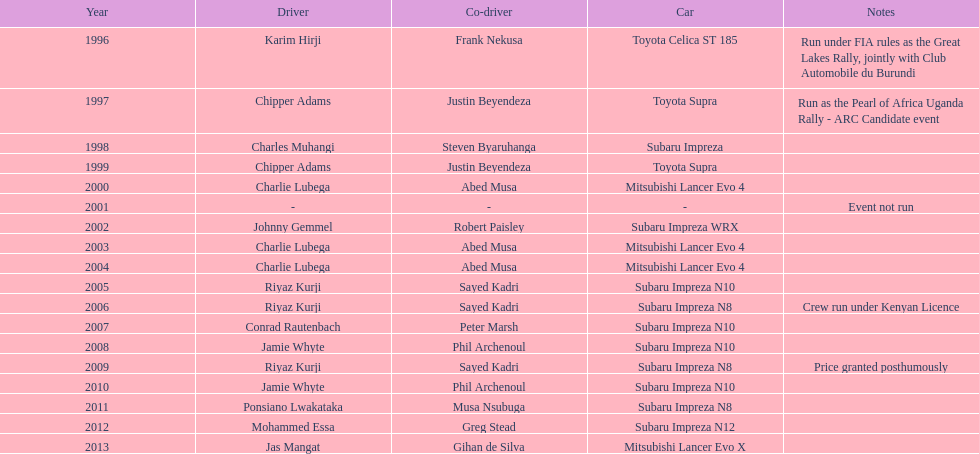How many drivers secured at least two victories? 4. 